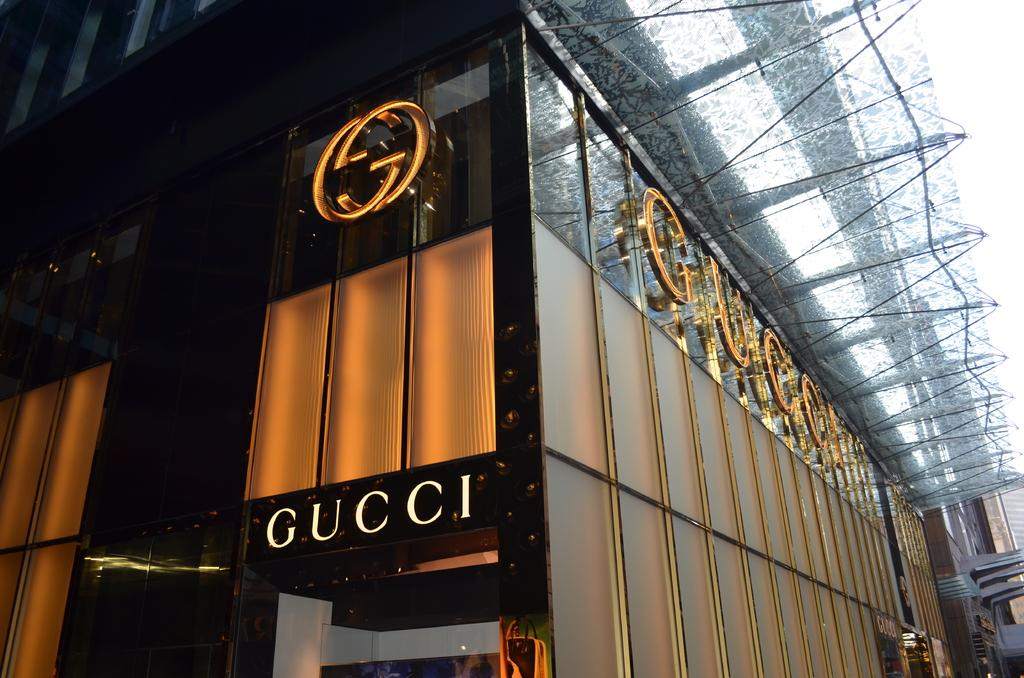What is the main subject of the image? The main subject of the image is a building. Are there any words or letters on the building? Yes, there is text on the building. What can be seen in the background of the image? The sky is visible at the top of the image. What shape is the sink in the image? There is no sink present in the image; it is a picture of a building with text on it. 